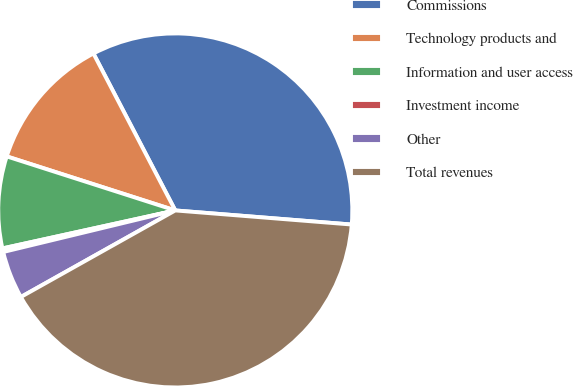Convert chart to OTSL. <chart><loc_0><loc_0><loc_500><loc_500><pie_chart><fcel>Commissions<fcel>Technology products and<fcel>Information and user access<fcel>Investment income<fcel>Other<fcel>Total revenues<nl><fcel>33.92%<fcel>12.41%<fcel>8.38%<fcel>0.33%<fcel>4.36%<fcel>40.6%<nl></chart> 